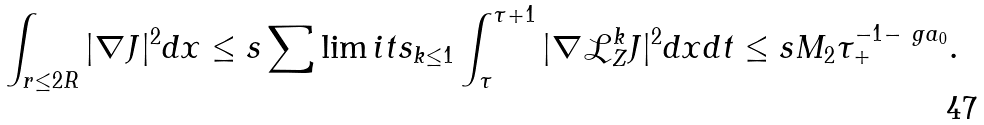Convert formula to latex. <formula><loc_0><loc_0><loc_500><loc_500>\int _ { r \leq 2 R } | \nabla J | ^ { 2 } d x \leq s \sum \lim i t s _ { k \leq 1 } \int _ { \tau } ^ { \tau + 1 } | \nabla \mathcal { L } _ { Z } ^ { k } J | ^ { 2 } d x d t \leq s M _ { 2 } \tau _ { + } ^ { - 1 - \ g a _ { 0 } } .</formula> 